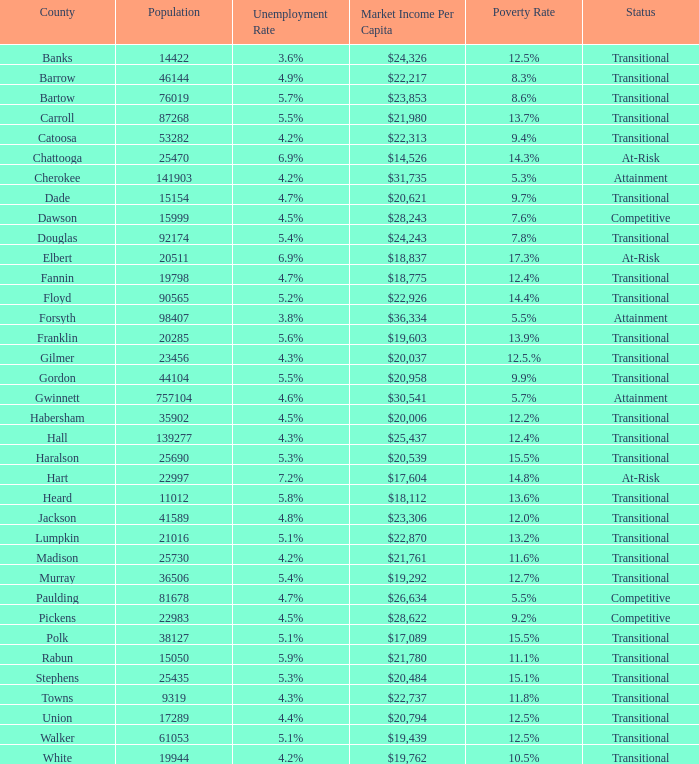3% poverty rate? At-Risk. 